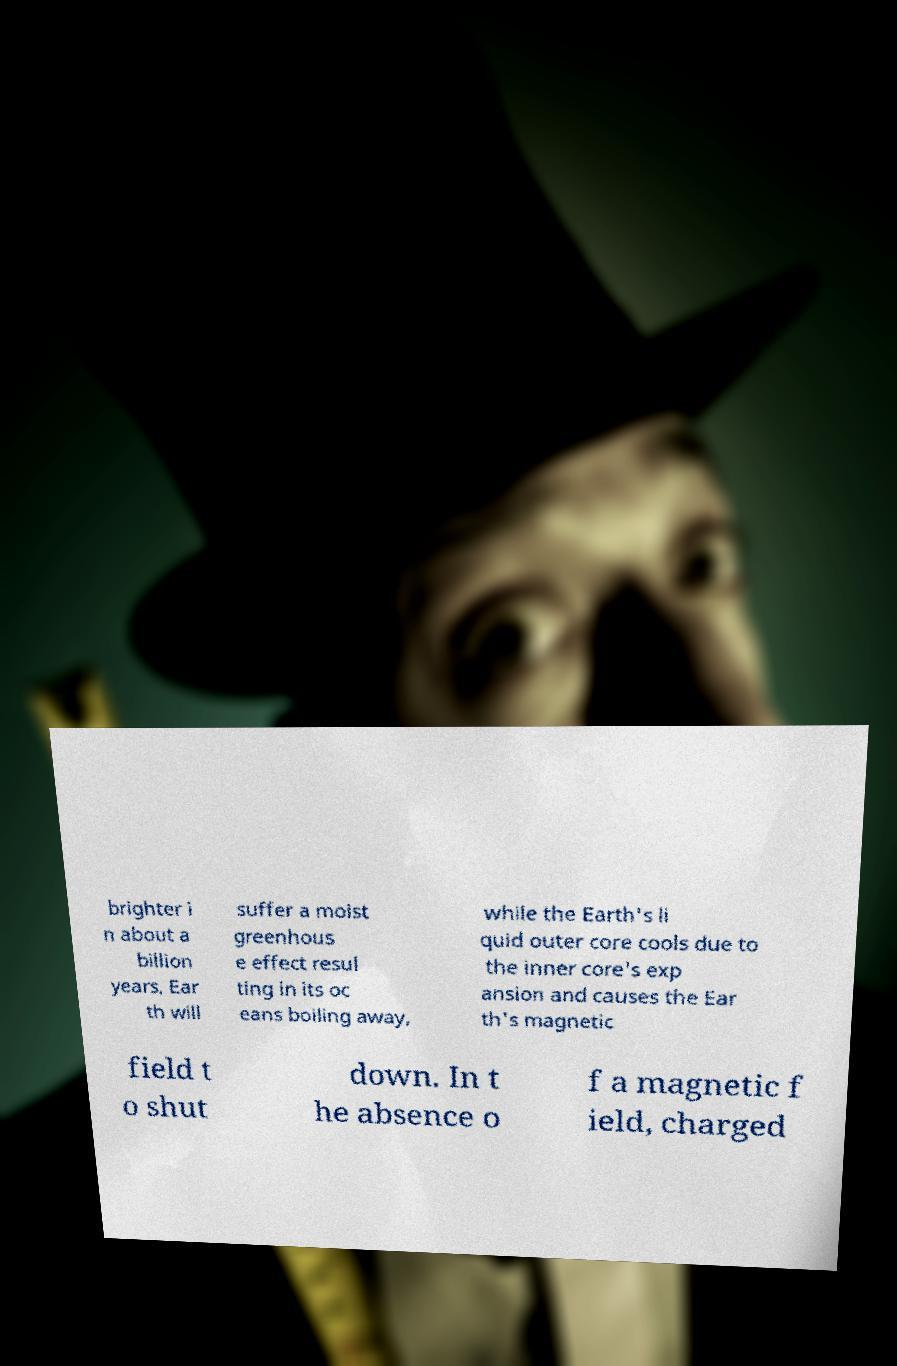There's text embedded in this image that I need extracted. Can you transcribe it verbatim? brighter i n about a billion years, Ear th will suffer a moist greenhous e effect resul ting in its oc eans boiling away, while the Earth's li quid outer core cools due to the inner core's exp ansion and causes the Ear th's magnetic field t o shut down. In t he absence o f a magnetic f ield, charged 